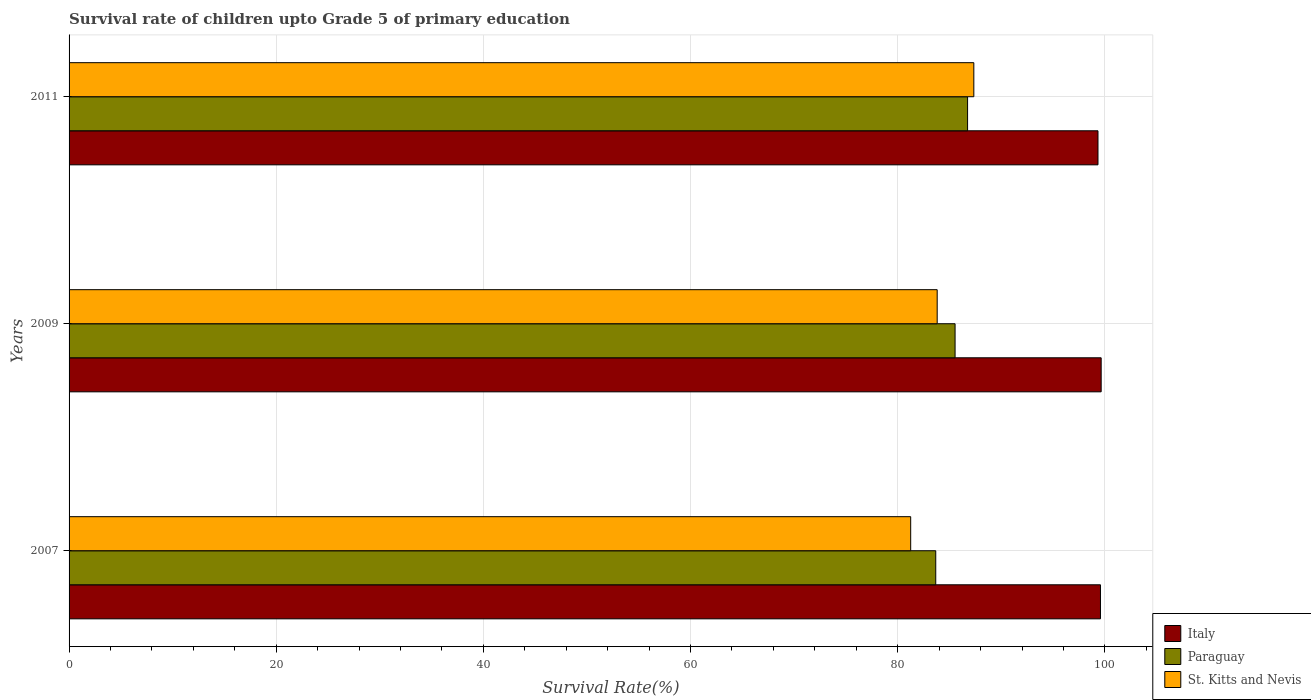How many different coloured bars are there?
Your response must be concise. 3. How many groups of bars are there?
Provide a short and direct response. 3. Are the number of bars per tick equal to the number of legend labels?
Give a very brief answer. Yes. How many bars are there on the 2nd tick from the top?
Your response must be concise. 3. What is the label of the 2nd group of bars from the top?
Provide a succinct answer. 2009. In how many cases, is the number of bars for a given year not equal to the number of legend labels?
Offer a very short reply. 0. What is the survival rate of children in Paraguay in 2007?
Provide a short and direct response. 83.67. Across all years, what is the maximum survival rate of children in St. Kitts and Nevis?
Your answer should be compact. 87.35. Across all years, what is the minimum survival rate of children in St. Kitts and Nevis?
Provide a succinct answer. 81.25. In which year was the survival rate of children in Italy maximum?
Make the answer very short. 2009. What is the total survival rate of children in St. Kitts and Nevis in the graph?
Your response must be concise. 252.41. What is the difference between the survival rate of children in Italy in 2009 and that in 2011?
Your answer should be compact. 0.31. What is the difference between the survival rate of children in Paraguay in 2011 and the survival rate of children in Italy in 2007?
Provide a succinct answer. -12.83. What is the average survival rate of children in Italy per year?
Provide a short and direct response. 99.52. In the year 2007, what is the difference between the survival rate of children in St. Kitts and Nevis and survival rate of children in Italy?
Make the answer very short. -18.32. What is the ratio of the survival rate of children in St. Kitts and Nevis in 2009 to that in 2011?
Offer a very short reply. 0.96. Is the survival rate of children in Italy in 2009 less than that in 2011?
Your answer should be compact. No. What is the difference between the highest and the second highest survival rate of children in Paraguay?
Give a very brief answer. 1.21. What is the difference between the highest and the lowest survival rate of children in St. Kitts and Nevis?
Provide a short and direct response. 6.09. In how many years, is the survival rate of children in Paraguay greater than the average survival rate of children in Paraguay taken over all years?
Provide a short and direct response. 2. Is the sum of the survival rate of children in Paraguay in 2009 and 2011 greater than the maximum survival rate of children in Italy across all years?
Ensure brevity in your answer.  Yes. What does the 3rd bar from the top in 2007 represents?
Provide a short and direct response. Italy. Is it the case that in every year, the sum of the survival rate of children in Paraguay and survival rate of children in St. Kitts and Nevis is greater than the survival rate of children in Italy?
Make the answer very short. Yes. How many bars are there?
Provide a short and direct response. 9. How many years are there in the graph?
Keep it short and to the point. 3. What is the difference between two consecutive major ticks on the X-axis?
Your answer should be compact. 20. Does the graph contain any zero values?
Your response must be concise. No. Does the graph contain grids?
Your response must be concise. Yes. How many legend labels are there?
Your response must be concise. 3. How are the legend labels stacked?
Your response must be concise. Vertical. What is the title of the graph?
Your answer should be compact. Survival rate of children upto Grade 5 of primary education. Does "French Polynesia" appear as one of the legend labels in the graph?
Give a very brief answer. No. What is the label or title of the X-axis?
Offer a very short reply. Survival Rate(%). What is the label or title of the Y-axis?
Ensure brevity in your answer.  Years. What is the Survival Rate(%) of Italy in 2007?
Your answer should be compact. 99.57. What is the Survival Rate(%) of Paraguay in 2007?
Give a very brief answer. 83.67. What is the Survival Rate(%) of St. Kitts and Nevis in 2007?
Ensure brevity in your answer.  81.25. What is the Survival Rate(%) of Italy in 2009?
Your response must be concise. 99.64. What is the Survival Rate(%) of Paraguay in 2009?
Offer a terse response. 85.54. What is the Survival Rate(%) of St. Kitts and Nevis in 2009?
Give a very brief answer. 83.81. What is the Survival Rate(%) in Italy in 2011?
Keep it short and to the point. 99.33. What is the Survival Rate(%) of Paraguay in 2011?
Ensure brevity in your answer.  86.74. What is the Survival Rate(%) of St. Kitts and Nevis in 2011?
Offer a very short reply. 87.35. Across all years, what is the maximum Survival Rate(%) in Italy?
Your answer should be compact. 99.64. Across all years, what is the maximum Survival Rate(%) in Paraguay?
Your response must be concise. 86.74. Across all years, what is the maximum Survival Rate(%) in St. Kitts and Nevis?
Provide a succinct answer. 87.35. Across all years, what is the minimum Survival Rate(%) of Italy?
Make the answer very short. 99.33. Across all years, what is the minimum Survival Rate(%) in Paraguay?
Provide a succinct answer. 83.67. Across all years, what is the minimum Survival Rate(%) of St. Kitts and Nevis?
Give a very brief answer. 81.25. What is the total Survival Rate(%) in Italy in the graph?
Ensure brevity in your answer.  298.55. What is the total Survival Rate(%) in Paraguay in the graph?
Your response must be concise. 255.95. What is the total Survival Rate(%) of St. Kitts and Nevis in the graph?
Offer a very short reply. 252.41. What is the difference between the Survival Rate(%) in Italy in 2007 and that in 2009?
Provide a succinct answer. -0.07. What is the difference between the Survival Rate(%) of Paraguay in 2007 and that in 2009?
Provide a short and direct response. -1.87. What is the difference between the Survival Rate(%) of St. Kitts and Nevis in 2007 and that in 2009?
Your answer should be very brief. -2.56. What is the difference between the Survival Rate(%) of Italy in 2007 and that in 2011?
Ensure brevity in your answer.  0.24. What is the difference between the Survival Rate(%) of Paraguay in 2007 and that in 2011?
Keep it short and to the point. -3.07. What is the difference between the Survival Rate(%) in St. Kitts and Nevis in 2007 and that in 2011?
Provide a succinct answer. -6.09. What is the difference between the Survival Rate(%) in Italy in 2009 and that in 2011?
Offer a terse response. 0.31. What is the difference between the Survival Rate(%) in Paraguay in 2009 and that in 2011?
Ensure brevity in your answer.  -1.21. What is the difference between the Survival Rate(%) in St. Kitts and Nevis in 2009 and that in 2011?
Give a very brief answer. -3.54. What is the difference between the Survival Rate(%) of Italy in 2007 and the Survival Rate(%) of Paraguay in 2009?
Make the answer very short. 14.04. What is the difference between the Survival Rate(%) in Italy in 2007 and the Survival Rate(%) in St. Kitts and Nevis in 2009?
Keep it short and to the point. 15.76. What is the difference between the Survival Rate(%) in Paraguay in 2007 and the Survival Rate(%) in St. Kitts and Nevis in 2009?
Provide a succinct answer. -0.14. What is the difference between the Survival Rate(%) of Italy in 2007 and the Survival Rate(%) of Paraguay in 2011?
Your answer should be compact. 12.83. What is the difference between the Survival Rate(%) of Italy in 2007 and the Survival Rate(%) of St. Kitts and Nevis in 2011?
Your answer should be very brief. 12.23. What is the difference between the Survival Rate(%) in Paraguay in 2007 and the Survival Rate(%) in St. Kitts and Nevis in 2011?
Offer a very short reply. -3.68. What is the difference between the Survival Rate(%) in Italy in 2009 and the Survival Rate(%) in Paraguay in 2011?
Provide a short and direct response. 12.9. What is the difference between the Survival Rate(%) in Italy in 2009 and the Survival Rate(%) in St. Kitts and Nevis in 2011?
Your response must be concise. 12.29. What is the difference between the Survival Rate(%) in Paraguay in 2009 and the Survival Rate(%) in St. Kitts and Nevis in 2011?
Give a very brief answer. -1.81. What is the average Survival Rate(%) in Italy per year?
Offer a terse response. 99.52. What is the average Survival Rate(%) of Paraguay per year?
Provide a short and direct response. 85.32. What is the average Survival Rate(%) of St. Kitts and Nevis per year?
Keep it short and to the point. 84.14. In the year 2007, what is the difference between the Survival Rate(%) of Italy and Survival Rate(%) of Paraguay?
Provide a succinct answer. 15.9. In the year 2007, what is the difference between the Survival Rate(%) in Italy and Survival Rate(%) in St. Kitts and Nevis?
Your response must be concise. 18.32. In the year 2007, what is the difference between the Survival Rate(%) of Paraguay and Survival Rate(%) of St. Kitts and Nevis?
Make the answer very short. 2.42. In the year 2009, what is the difference between the Survival Rate(%) in Italy and Survival Rate(%) in Paraguay?
Your answer should be very brief. 14.1. In the year 2009, what is the difference between the Survival Rate(%) in Italy and Survival Rate(%) in St. Kitts and Nevis?
Your response must be concise. 15.83. In the year 2009, what is the difference between the Survival Rate(%) of Paraguay and Survival Rate(%) of St. Kitts and Nevis?
Make the answer very short. 1.73. In the year 2011, what is the difference between the Survival Rate(%) of Italy and Survival Rate(%) of Paraguay?
Provide a succinct answer. 12.59. In the year 2011, what is the difference between the Survival Rate(%) of Italy and Survival Rate(%) of St. Kitts and Nevis?
Your answer should be very brief. 11.99. In the year 2011, what is the difference between the Survival Rate(%) of Paraguay and Survival Rate(%) of St. Kitts and Nevis?
Ensure brevity in your answer.  -0.6. What is the ratio of the Survival Rate(%) in Paraguay in 2007 to that in 2009?
Ensure brevity in your answer.  0.98. What is the ratio of the Survival Rate(%) in St. Kitts and Nevis in 2007 to that in 2009?
Give a very brief answer. 0.97. What is the ratio of the Survival Rate(%) of Paraguay in 2007 to that in 2011?
Provide a succinct answer. 0.96. What is the ratio of the Survival Rate(%) in St. Kitts and Nevis in 2007 to that in 2011?
Give a very brief answer. 0.93. What is the ratio of the Survival Rate(%) in Italy in 2009 to that in 2011?
Offer a terse response. 1. What is the ratio of the Survival Rate(%) in Paraguay in 2009 to that in 2011?
Your answer should be very brief. 0.99. What is the ratio of the Survival Rate(%) of St. Kitts and Nevis in 2009 to that in 2011?
Provide a short and direct response. 0.96. What is the difference between the highest and the second highest Survival Rate(%) in Italy?
Offer a very short reply. 0.07. What is the difference between the highest and the second highest Survival Rate(%) in Paraguay?
Your answer should be very brief. 1.21. What is the difference between the highest and the second highest Survival Rate(%) in St. Kitts and Nevis?
Offer a very short reply. 3.54. What is the difference between the highest and the lowest Survival Rate(%) in Italy?
Your answer should be very brief. 0.31. What is the difference between the highest and the lowest Survival Rate(%) of Paraguay?
Your answer should be compact. 3.07. What is the difference between the highest and the lowest Survival Rate(%) of St. Kitts and Nevis?
Provide a short and direct response. 6.09. 